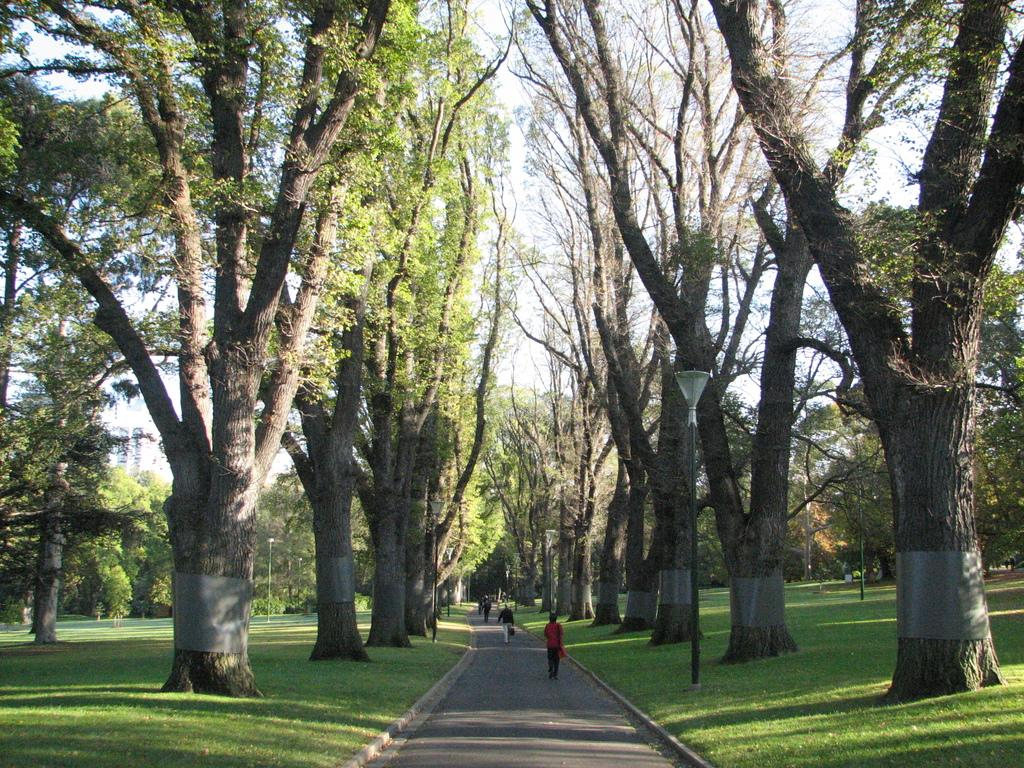What are the people in the image doing? The people in the image are walking on the road. What can be seen in the background of the image? The sky, clouds, trees, poles, and grass are visible in the background of the image. What type of glue is being used by the people walking on the road in the image? There is no glue present in the image, and the people walking on the road are not using any glue. Can you tell me what color the orange is in the image? There is no orange present in the image. 